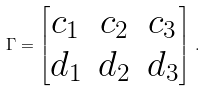<formula> <loc_0><loc_0><loc_500><loc_500>\Gamma = \begin{bmatrix} c _ { 1 } & c _ { 2 } & c _ { 3 } \\ d _ { 1 } & d _ { 2 } & d _ { 3 } \end{bmatrix} \, .</formula> 